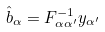Convert formula to latex. <formula><loc_0><loc_0><loc_500><loc_500>\hat { b } _ { \alpha } = F _ { \alpha \alpha ^ { \prime } } ^ { - 1 } y _ { \alpha ^ { \prime } }</formula> 